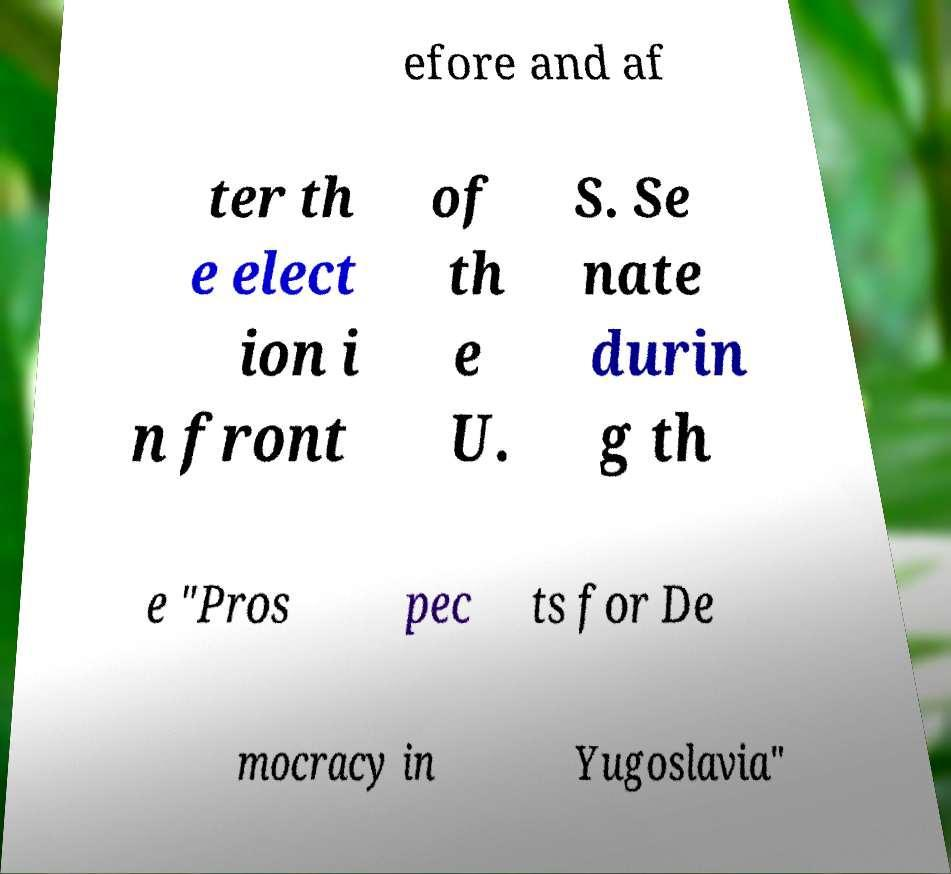Can you accurately transcribe the text from the provided image for me? efore and af ter th e elect ion i n front of th e U. S. Se nate durin g th e "Pros pec ts for De mocracy in Yugoslavia" 